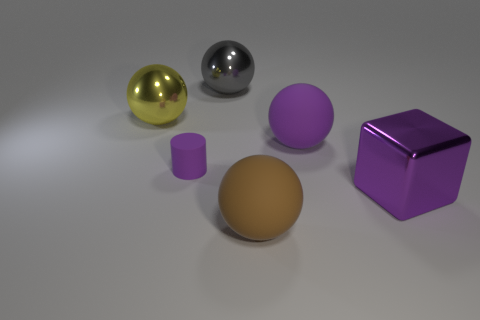Add 2 purple cylinders. How many objects exist? 8 Subtract all cylinders. How many objects are left? 5 Add 4 large shiny things. How many large shiny things are left? 7 Add 1 large red metal things. How many large red metal things exist? 1 Subtract 0 cyan cubes. How many objects are left? 6 Subtract all purple shiny cylinders. Subtract all large yellow metal balls. How many objects are left? 5 